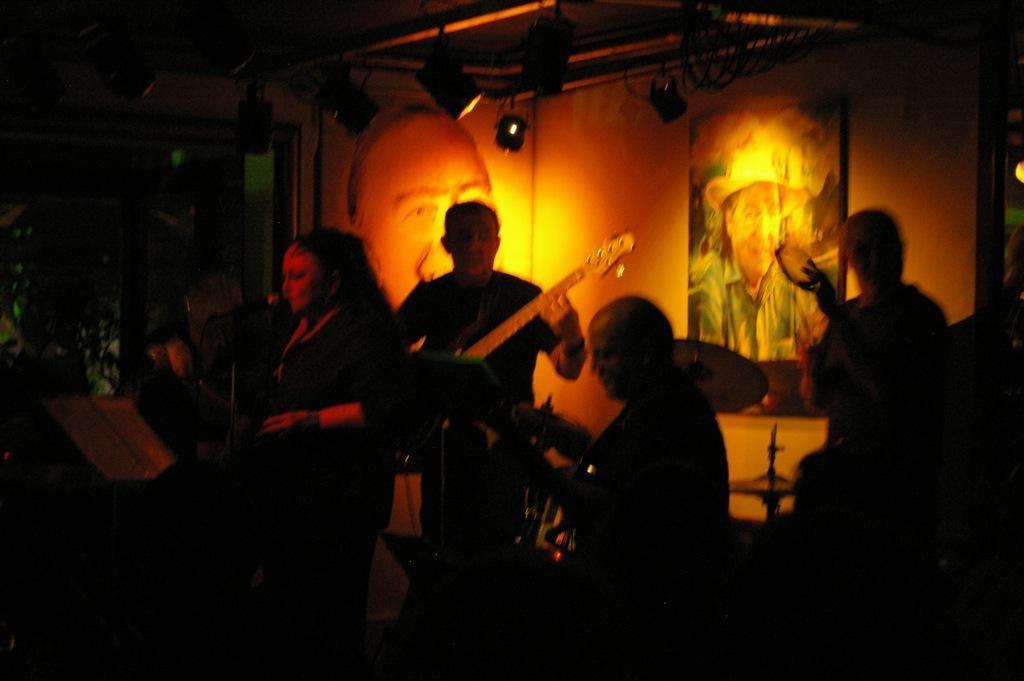How would you summarize this image in a sentence or two? In this picture we can see a group of people holding the music instruments and in front of the woman there is a microphone. Behind the people there is a wall with photo frames and on the top there are lights. 